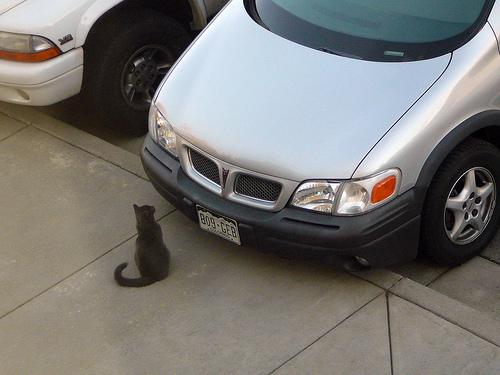Question: how many cats are there?
Choices:
A. One.
B. Two.
C. Three.
D. Four.
Answer with the letter. Answer: A Question: what color are the cars?
Choices:
A. Blue.
B. Green.
C. Red.
D. White and silver.
Answer with the letter. Answer: D Question: what color is the ground?
Choices:
A. Blue.
B. Grey.
C. Green.
D. Yellow.
Answer with the letter. Answer: B Question: who is looking at the car?
Choices:
A. The dog.
B. The boy.
C. The cat.
D. The girl.
Answer with the letter. Answer: C 